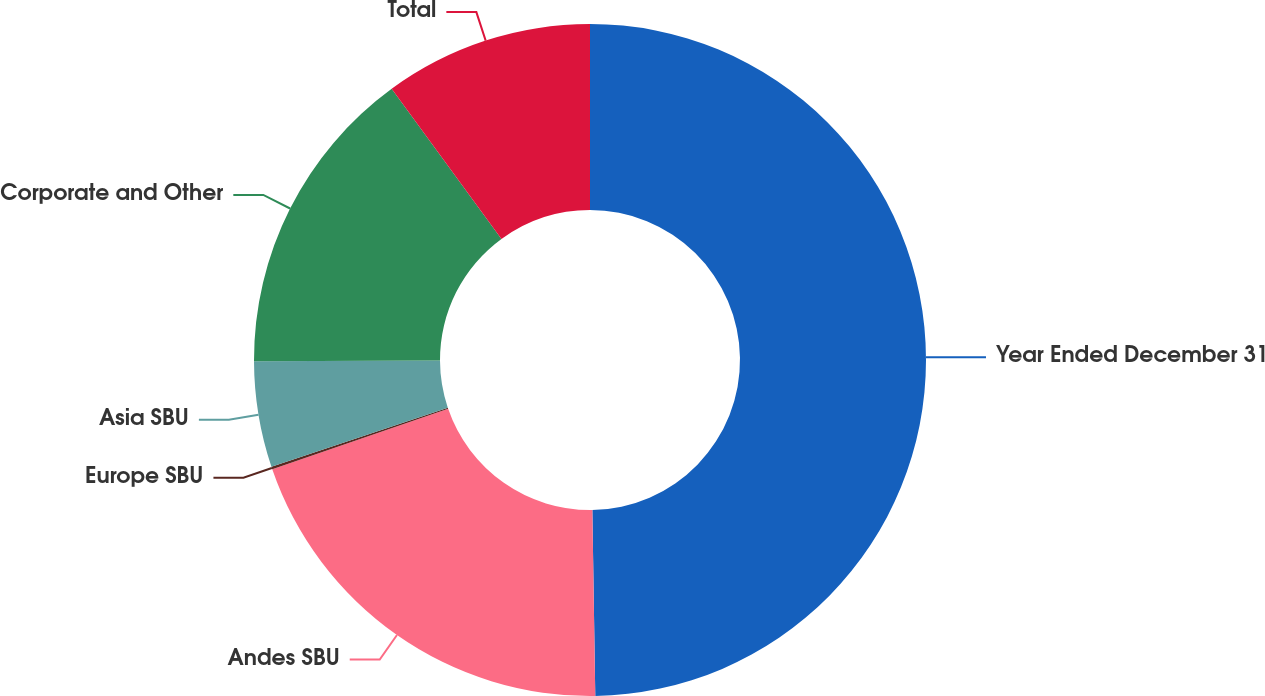Convert chart. <chart><loc_0><loc_0><loc_500><loc_500><pie_chart><fcel>Year Ended December 31<fcel>Andes SBU<fcel>Europe SBU<fcel>Asia SBU<fcel>Corporate and Other<fcel>Total<nl><fcel>49.75%<fcel>19.98%<fcel>0.12%<fcel>5.09%<fcel>15.01%<fcel>10.05%<nl></chart> 